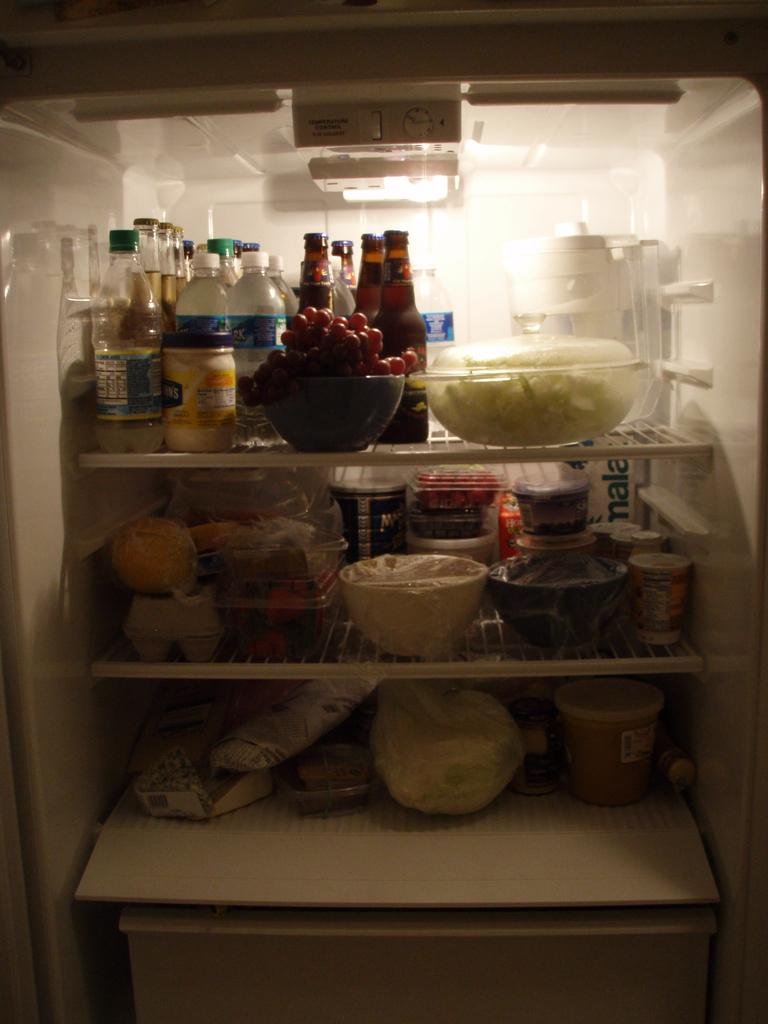Provide a one-sentence caption for the provided image. A full fridge with a box in it that has the word mala on it. 